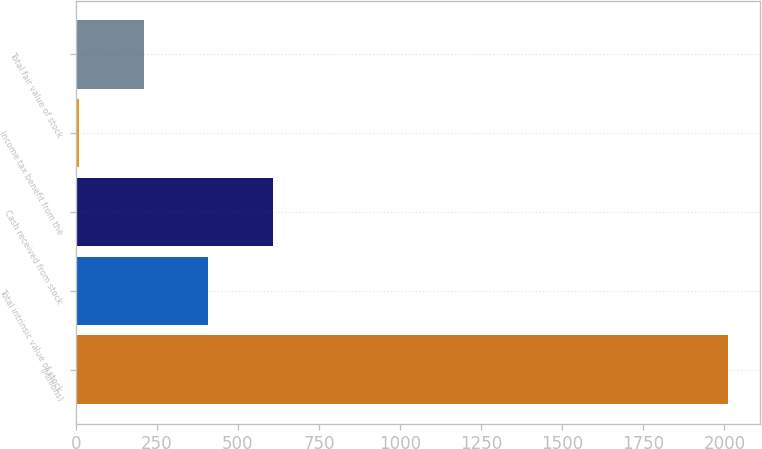<chart> <loc_0><loc_0><loc_500><loc_500><bar_chart><fcel>(Millions)<fcel>Total intrinsic value of stock<fcel>Cash received from stock<fcel>Income tax benefit from the<fcel>Total fair value of stock<nl><fcel>2010<fcel>409.2<fcel>609.3<fcel>9<fcel>209.1<nl></chart> 